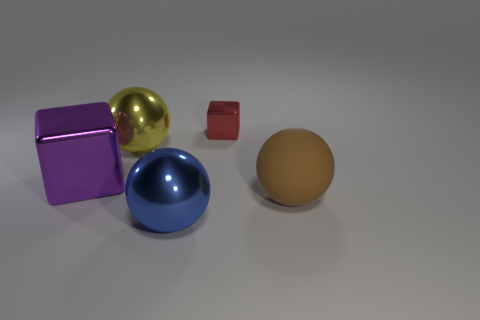Add 1 large yellow metallic spheres. How many objects exist? 6 Subtract all cubes. How many objects are left? 3 Subtract 1 yellow balls. How many objects are left? 4 Subtract all metallic cubes. Subtract all large metallic objects. How many objects are left? 0 Add 5 small objects. How many small objects are left? 6 Add 3 tiny red metallic blocks. How many tiny red metallic blocks exist? 4 